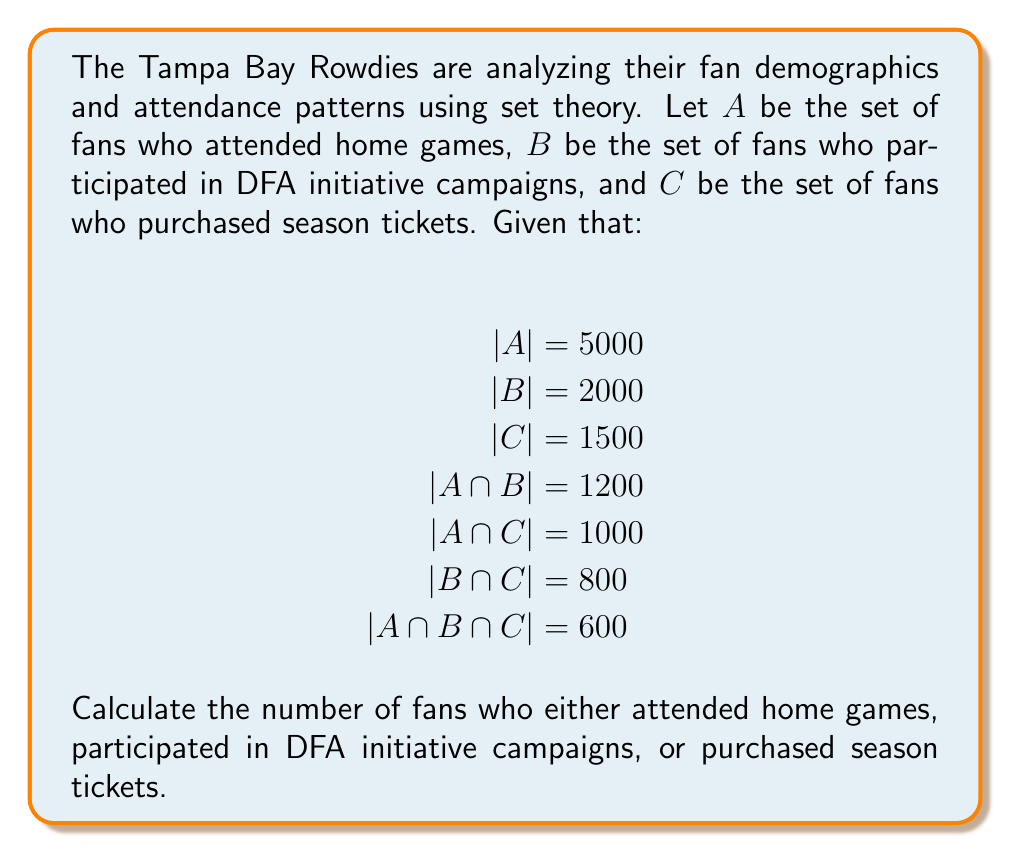Show me your answer to this math problem. To solve this problem, we need to use the principle of inclusion-exclusion for three sets. The formula is:

$$|A \cup B \cup C| = |A| + |B| + |C| - |A \cap B| - |A \cap C| - |B \cap C| + |A \cap B \cap C|$$

Let's substitute the given values:

$$|A \cup B \cup C| = 5000 + 2000 + 1500 - 1200 - 1000 - 800 + 600$$

Now, let's calculate step by step:

1. Add the individual set sizes:
   $5000 + 2000 + 1500 = 8500$

2. Subtract the pairwise intersections:
   $8500 - 1200 - 1000 - 800 = 5500$

3. Add back the triple intersection:
   $5500 + 600 = 6100$

Therefore, the total number of fans who either attended home games, participated in DFA initiative campaigns, or purchased season tickets is 6100.
Answer: 6100 fans 